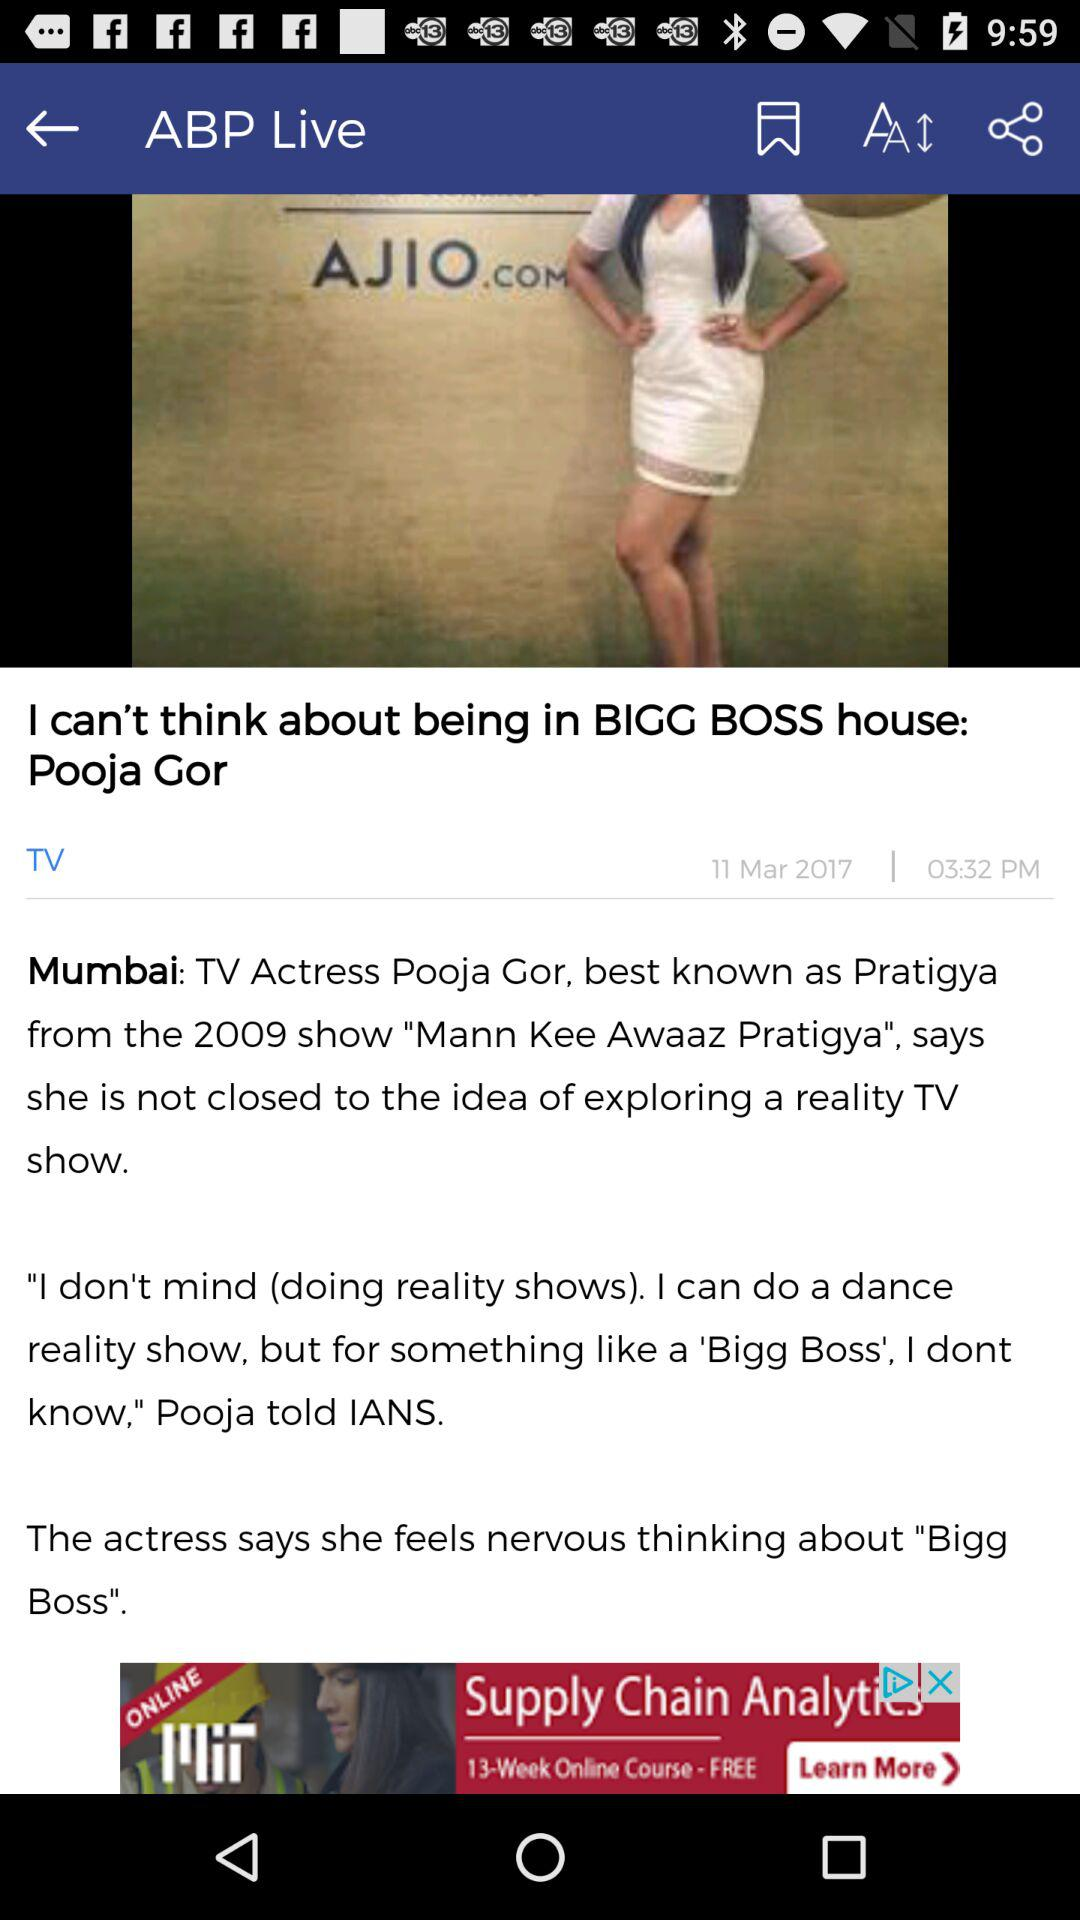On what date was the article published? The article was published on March 11, 2017. 